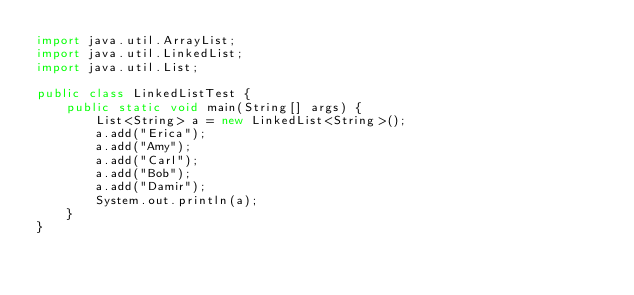Convert code to text. <code><loc_0><loc_0><loc_500><loc_500><_Java_>import java.util.ArrayList;
import java.util.LinkedList;
import java.util.List;

public class LinkedListTest {
    public static void main(String[] args) {
        List<String> a = new LinkedList<String>();
        a.add("Erica");
        a.add("Amy");
        a.add("Carl");
        a.add("Bob");
        a.add("Damir");
        System.out.println(a);
    }
}
</code> 